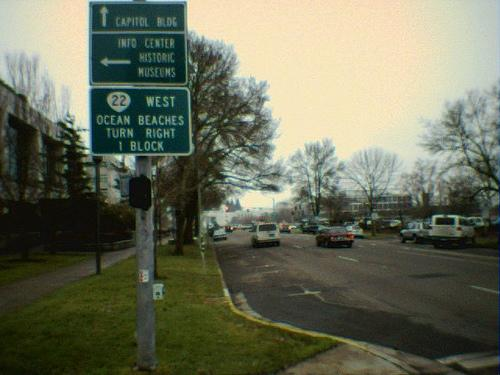What type of signs are these? Please explain your reasoning. directional. The signs are pointing to different areas. 